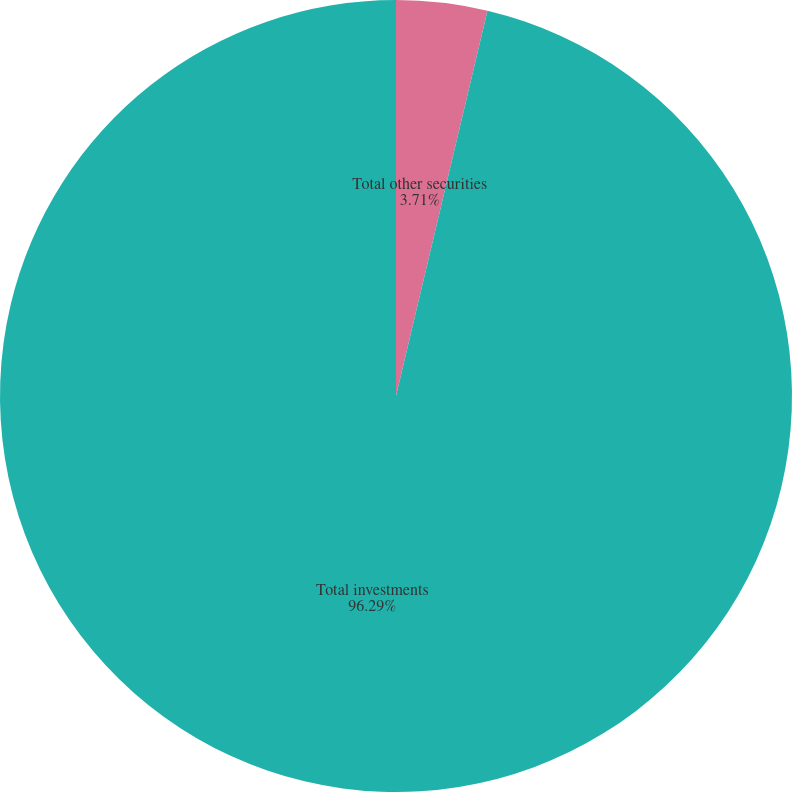Convert chart. <chart><loc_0><loc_0><loc_500><loc_500><pie_chart><fcel>Total other securities<fcel>Total investments<nl><fcel>3.71%<fcel>96.29%<nl></chart> 